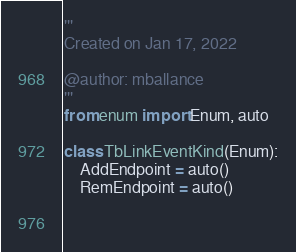<code> <loc_0><loc_0><loc_500><loc_500><_Python_>'''
Created on Jan 17, 2022

@author: mballance
'''
from enum import Enum, auto

class TbLinkEventKind(Enum):
    AddEndpoint = auto()
    RemEndpoint = auto()
    
    </code> 